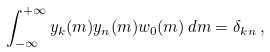<formula> <loc_0><loc_0><loc_500><loc_500>\int _ { - \infty } ^ { + \infty } y _ { k } ( m ) y _ { n } ( m ) w _ { 0 } ( m ) \, d m = \delta _ { k n } \, ,</formula> 